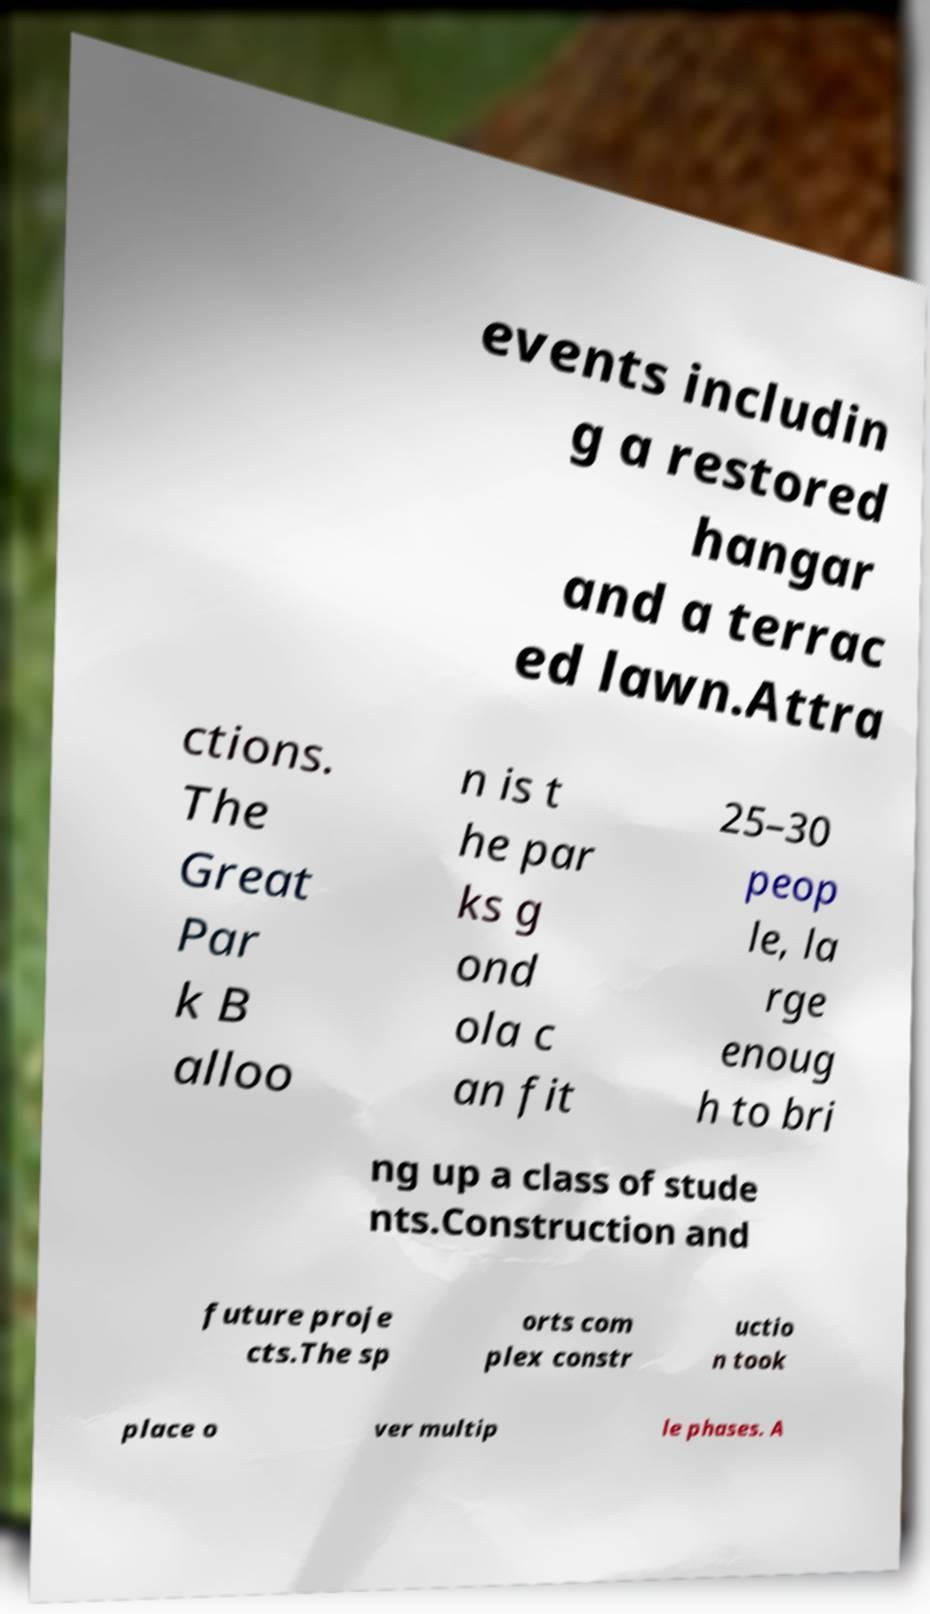Please identify and transcribe the text found in this image. events includin g a restored hangar and a terrac ed lawn.Attra ctions. The Great Par k B alloo n is t he par ks g ond ola c an fit 25–30 peop le, la rge enoug h to bri ng up a class of stude nts.Construction and future proje cts.The sp orts com plex constr uctio n took place o ver multip le phases. A 